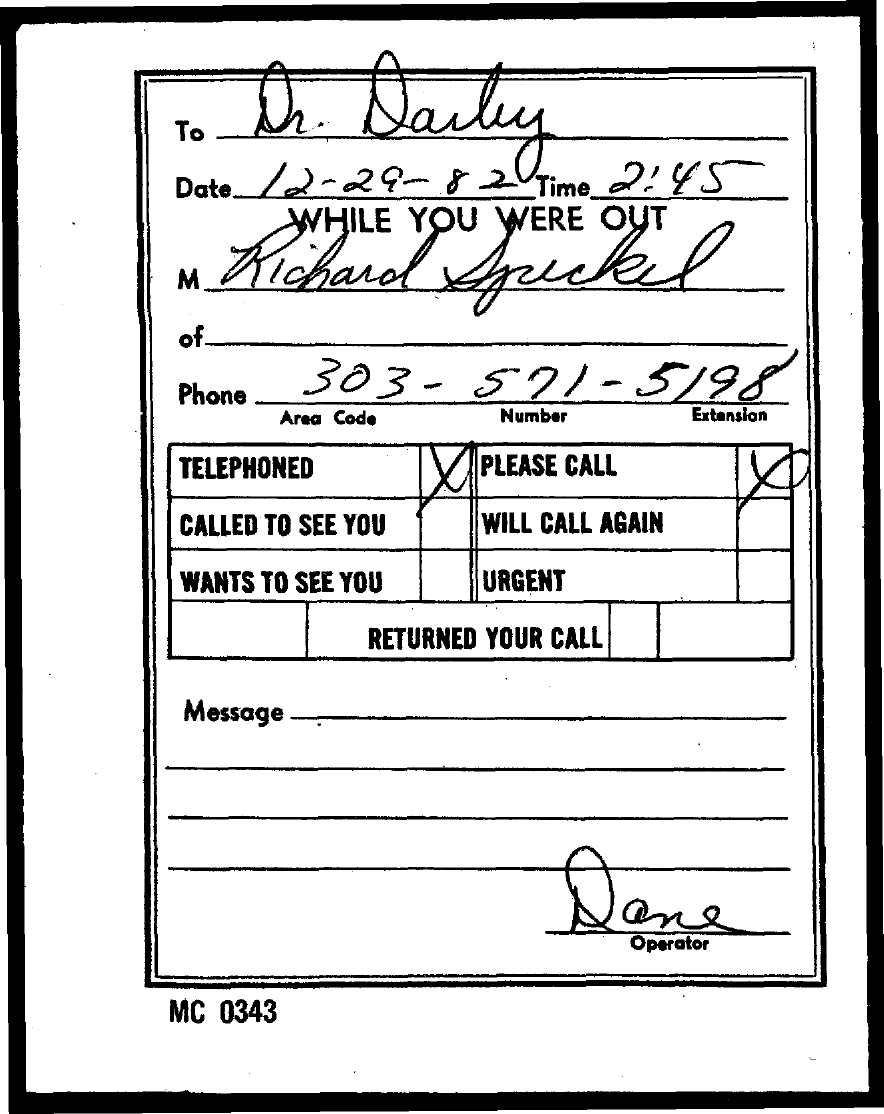Point out several critical features in this image. The document mentions the time as 2:45. The area code is 303... The date mentioned in the document is December 29, 1982. 